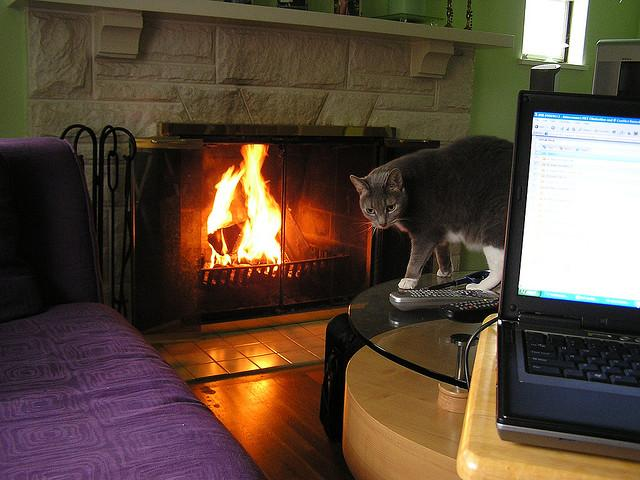What is creeping around on the table?

Choices:
A) mouse
B) monkey
C) cat
D) dog cat 